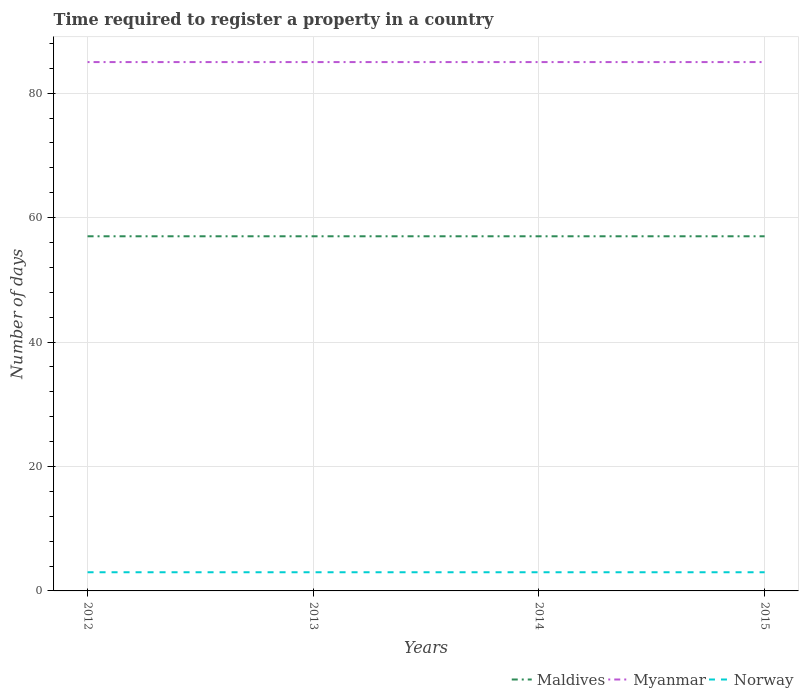How many different coloured lines are there?
Make the answer very short. 3. Is the number of lines equal to the number of legend labels?
Ensure brevity in your answer.  Yes. In which year was the number of days required to register a property in Maldives maximum?
Offer a terse response. 2012. What is the difference between the highest and the second highest number of days required to register a property in Myanmar?
Ensure brevity in your answer.  0. What is the difference between the highest and the lowest number of days required to register a property in Myanmar?
Provide a succinct answer. 0. How many lines are there?
Keep it short and to the point. 3. What is the difference between two consecutive major ticks on the Y-axis?
Your response must be concise. 20. Where does the legend appear in the graph?
Provide a succinct answer. Bottom right. How many legend labels are there?
Your answer should be very brief. 3. How are the legend labels stacked?
Make the answer very short. Horizontal. What is the title of the graph?
Provide a short and direct response. Time required to register a property in a country. Does "France" appear as one of the legend labels in the graph?
Ensure brevity in your answer.  No. What is the label or title of the Y-axis?
Ensure brevity in your answer.  Number of days. What is the Number of days in Myanmar in 2013?
Make the answer very short. 85. What is the Number of days of Maldives in 2014?
Provide a short and direct response. 57. What is the Number of days of Myanmar in 2014?
Your answer should be compact. 85. What is the Number of days of Maldives in 2015?
Your response must be concise. 57. Across all years, what is the maximum Number of days of Myanmar?
Ensure brevity in your answer.  85. Across all years, what is the minimum Number of days in Maldives?
Your answer should be very brief. 57. What is the total Number of days of Maldives in the graph?
Offer a very short reply. 228. What is the total Number of days in Myanmar in the graph?
Offer a terse response. 340. What is the total Number of days in Norway in the graph?
Ensure brevity in your answer.  12. What is the difference between the Number of days of Myanmar in 2012 and that in 2013?
Your answer should be compact. 0. What is the difference between the Number of days of Norway in 2012 and that in 2013?
Your answer should be compact. 0. What is the difference between the Number of days of Maldives in 2012 and that in 2014?
Provide a short and direct response. 0. What is the difference between the Number of days of Norway in 2012 and that in 2014?
Provide a short and direct response. 0. What is the difference between the Number of days in Myanmar in 2012 and that in 2015?
Your response must be concise. 0. What is the difference between the Number of days in Norway in 2012 and that in 2015?
Provide a short and direct response. 0. What is the difference between the Number of days of Myanmar in 2013 and that in 2014?
Your answer should be very brief. 0. What is the difference between the Number of days in Maldives in 2013 and that in 2015?
Keep it short and to the point. 0. What is the difference between the Number of days of Norway in 2013 and that in 2015?
Give a very brief answer. 0. What is the difference between the Number of days in Maldives in 2014 and that in 2015?
Provide a succinct answer. 0. What is the difference between the Number of days of Myanmar in 2014 and that in 2015?
Your response must be concise. 0. What is the difference between the Number of days in Maldives in 2012 and the Number of days in Myanmar in 2013?
Give a very brief answer. -28. What is the difference between the Number of days in Maldives in 2012 and the Number of days in Norway in 2013?
Your answer should be very brief. 54. What is the difference between the Number of days in Maldives in 2012 and the Number of days in Myanmar in 2014?
Offer a terse response. -28. What is the difference between the Number of days in Maldives in 2012 and the Number of days in Norway in 2014?
Your answer should be compact. 54. What is the difference between the Number of days in Maldives in 2012 and the Number of days in Norway in 2015?
Offer a very short reply. 54. What is the difference between the Number of days in Myanmar in 2012 and the Number of days in Norway in 2015?
Offer a terse response. 82. What is the difference between the Number of days of Maldives in 2013 and the Number of days of Myanmar in 2015?
Keep it short and to the point. -28. What is the difference between the Number of days of Maldives in 2014 and the Number of days of Myanmar in 2015?
Offer a very short reply. -28. What is the difference between the Number of days in Maldives in 2014 and the Number of days in Norway in 2015?
Ensure brevity in your answer.  54. What is the average Number of days of Maldives per year?
Make the answer very short. 57. What is the average Number of days in Norway per year?
Ensure brevity in your answer.  3. In the year 2012, what is the difference between the Number of days in Maldives and Number of days in Myanmar?
Provide a succinct answer. -28. In the year 2012, what is the difference between the Number of days of Myanmar and Number of days of Norway?
Your response must be concise. 82. In the year 2013, what is the difference between the Number of days of Maldives and Number of days of Norway?
Your answer should be compact. 54. In the year 2014, what is the difference between the Number of days in Maldives and Number of days in Myanmar?
Your answer should be very brief. -28. In the year 2014, what is the difference between the Number of days in Maldives and Number of days in Norway?
Give a very brief answer. 54. In the year 2014, what is the difference between the Number of days in Myanmar and Number of days in Norway?
Ensure brevity in your answer.  82. In the year 2015, what is the difference between the Number of days in Maldives and Number of days in Myanmar?
Your answer should be very brief. -28. What is the ratio of the Number of days of Maldives in 2012 to that in 2014?
Your answer should be compact. 1. What is the ratio of the Number of days of Myanmar in 2012 to that in 2015?
Give a very brief answer. 1. What is the ratio of the Number of days of Norway in 2012 to that in 2015?
Offer a terse response. 1. What is the ratio of the Number of days of Maldives in 2014 to that in 2015?
Offer a terse response. 1. What is the ratio of the Number of days of Myanmar in 2014 to that in 2015?
Give a very brief answer. 1. What is the difference between the highest and the second highest Number of days of Maldives?
Give a very brief answer. 0. What is the difference between the highest and the second highest Number of days of Myanmar?
Keep it short and to the point. 0. What is the difference between the highest and the lowest Number of days in Maldives?
Your answer should be compact. 0. What is the difference between the highest and the lowest Number of days in Myanmar?
Ensure brevity in your answer.  0. 